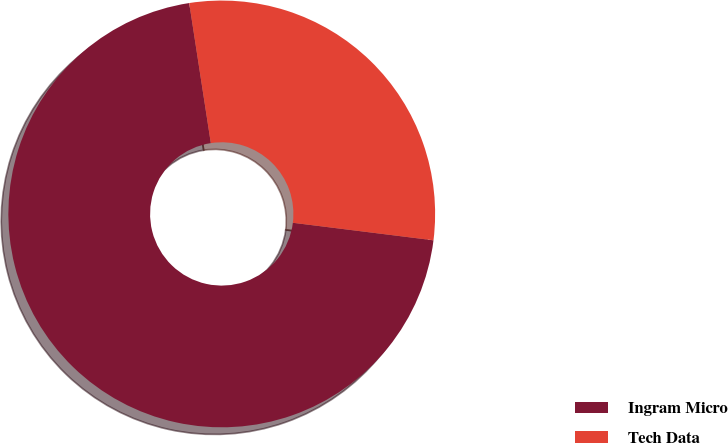<chart> <loc_0><loc_0><loc_500><loc_500><pie_chart><fcel>Ingram Micro<fcel>Tech Data<nl><fcel>70.59%<fcel>29.41%<nl></chart> 